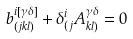Convert formula to latex. <formula><loc_0><loc_0><loc_500><loc_500>b _ { ( j k l ) } ^ { i [ \gamma \delta ] } + \delta ^ { i } _ { ( j } A _ { k l ) } ^ { \gamma \delta } = 0</formula> 